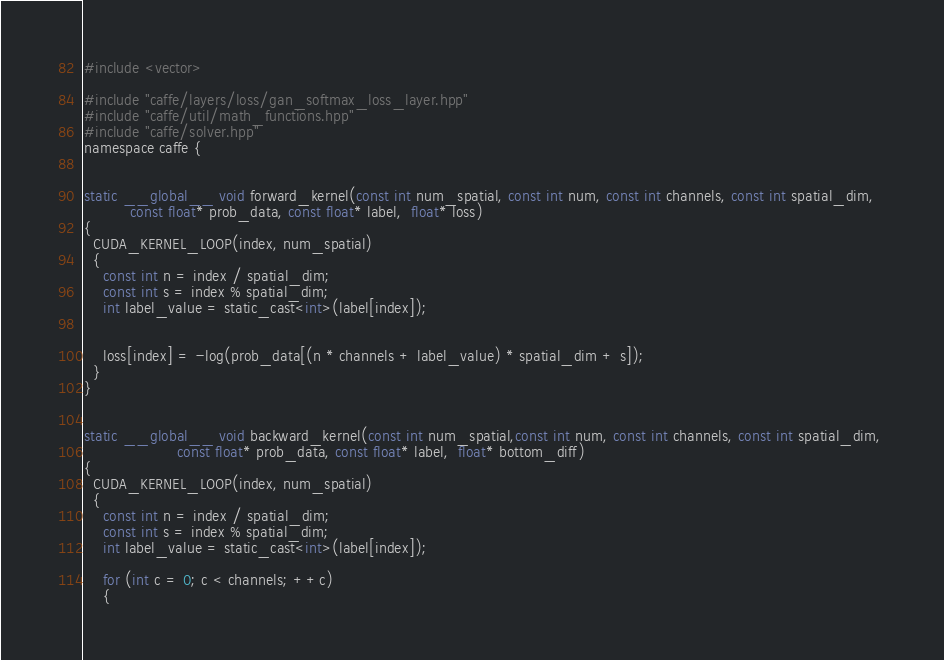<code> <loc_0><loc_0><loc_500><loc_500><_Cuda_>
#include <vector>

#include "caffe/layers/loss/gan_softmax_loss_layer.hpp"
#include "caffe/util/math_functions.hpp"
#include "caffe/solver.hpp"
namespace caffe {


static __global__ void forward_kernel(const int num_spatial, const int num, const int channels, const int spatial_dim,
          const float* prob_data, const float* label,  float* loss) 
{
  CUDA_KERNEL_LOOP(index, num_spatial) 
  {
    const int n = index / spatial_dim;
    const int s = index % spatial_dim;
    int label_value = static_cast<int>(label[index]);
   		

    loss[index] = -log(prob_data[(n * channels + label_value) * spatial_dim + s]);
  }
}


static __global__ void backward_kernel(const int num_spatial,const int num, const int channels, const int spatial_dim, 
					const float* prob_data, const float* label,  float* bottom_diff) 
{
  CUDA_KERNEL_LOOP(index, num_spatial) 
  {
    const int n = index / spatial_dim;
    const int s = index % spatial_dim;
    int label_value = static_cast<int>(label[index]);
		
  	for (int c = 0; c < channels; ++c) 
    {</code> 